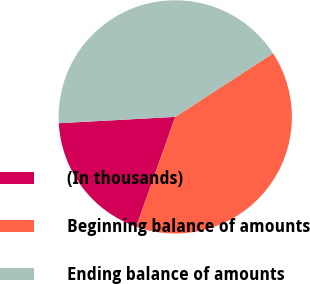Convert chart. <chart><loc_0><loc_0><loc_500><loc_500><pie_chart><fcel>(In thousands)<fcel>Beginning balance of amounts<fcel>Ending balance of amounts<nl><fcel>18.7%<fcel>39.6%<fcel>41.69%<nl></chart> 